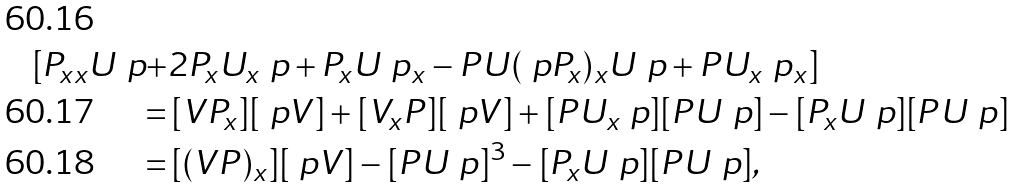<formula> <loc_0><loc_0><loc_500><loc_500>[ P _ { x x } U \ p + & 2 P _ { x } U _ { x } \ p + P _ { x } U \ p _ { x } - P U ( \ p P _ { x } ) _ { x } U \ p + P U _ { x } \ p _ { x } ] \\ = & \, [ V P _ { x } ] [ \ p V ] + [ V _ { x } P ] [ \ p V ] + [ P U _ { x } \ p ] [ P U \ p ] - [ P _ { x } U \ p ] [ P U \ p ] \\ = & \, [ ( V P ) _ { x } ] [ \ p V ] - [ P U \ p ] ^ { 3 } - [ P _ { x } U \ p ] [ P U \ p ] ,</formula> 